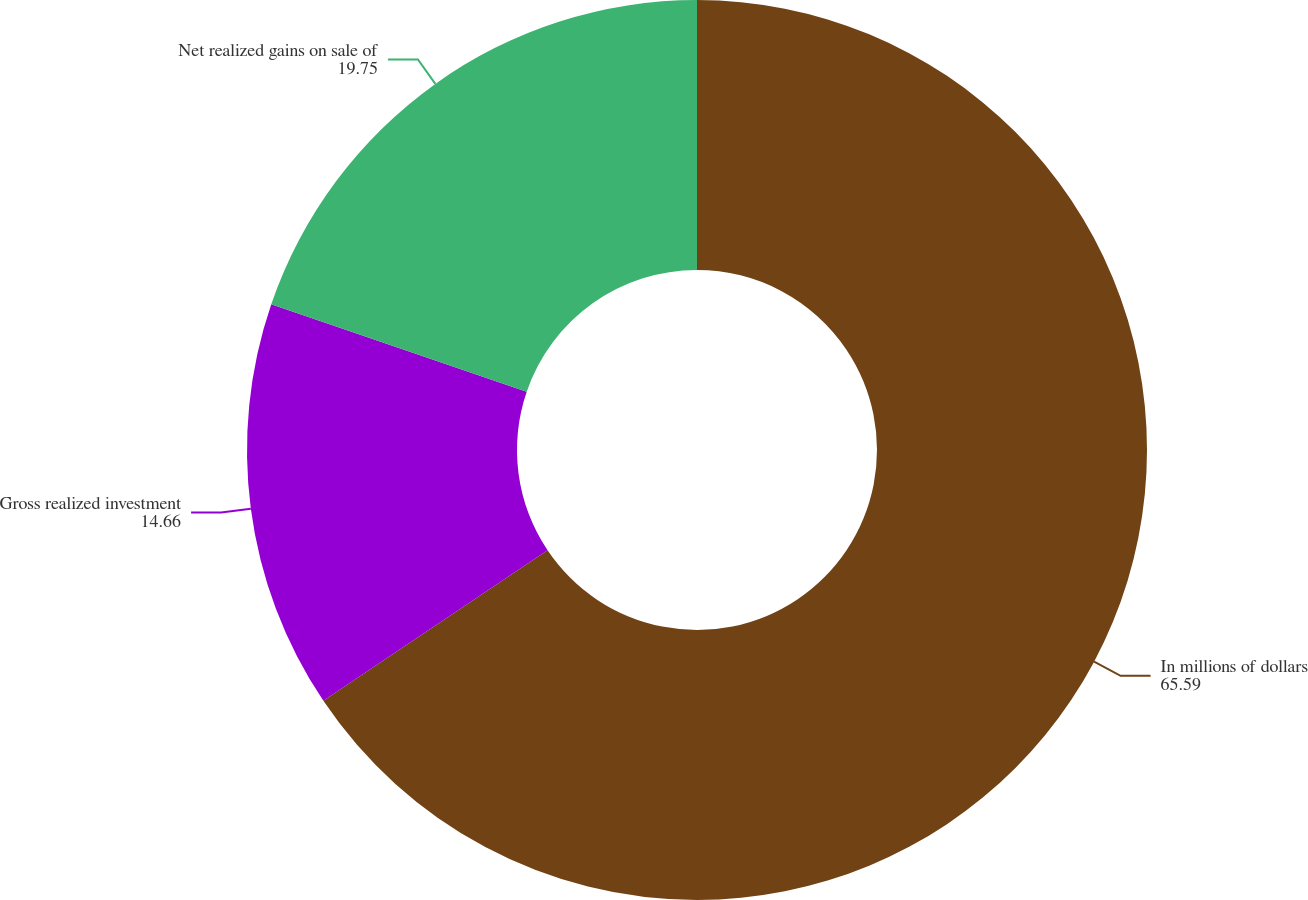Convert chart. <chart><loc_0><loc_0><loc_500><loc_500><pie_chart><fcel>In millions of dollars<fcel>Gross realized investment<fcel>Net realized gains on sale of<nl><fcel>65.59%<fcel>14.66%<fcel>19.75%<nl></chart> 